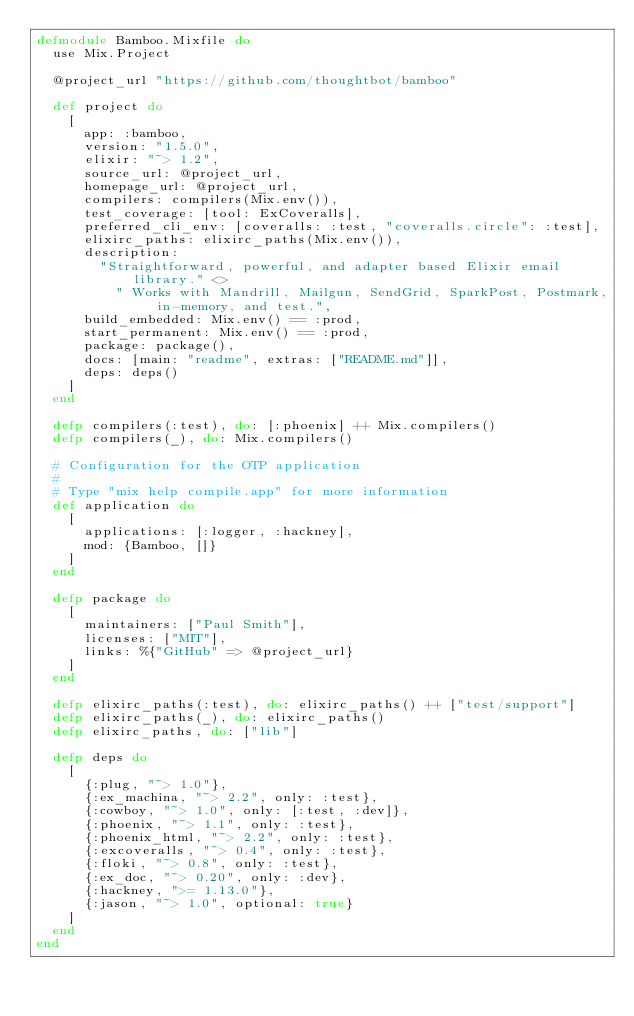Convert code to text. <code><loc_0><loc_0><loc_500><loc_500><_Elixir_>defmodule Bamboo.Mixfile do
  use Mix.Project

  @project_url "https://github.com/thoughtbot/bamboo"

  def project do
    [
      app: :bamboo,
      version: "1.5.0",
      elixir: "~> 1.2",
      source_url: @project_url,
      homepage_url: @project_url,
      compilers: compilers(Mix.env()),
      test_coverage: [tool: ExCoveralls],
      preferred_cli_env: [coveralls: :test, "coveralls.circle": :test],
      elixirc_paths: elixirc_paths(Mix.env()),
      description:
        "Straightforward, powerful, and adapter based Elixir email library." <>
          " Works with Mandrill, Mailgun, SendGrid, SparkPost, Postmark, in-memory, and test.",
      build_embedded: Mix.env() == :prod,
      start_permanent: Mix.env() == :prod,
      package: package(),
      docs: [main: "readme", extras: ["README.md"]],
      deps: deps()
    ]
  end

  defp compilers(:test), do: [:phoenix] ++ Mix.compilers()
  defp compilers(_), do: Mix.compilers()

  # Configuration for the OTP application
  #
  # Type "mix help compile.app" for more information
  def application do
    [
      applications: [:logger, :hackney],
      mod: {Bamboo, []}
    ]
  end

  defp package do
    [
      maintainers: ["Paul Smith"],
      licenses: ["MIT"],
      links: %{"GitHub" => @project_url}
    ]
  end

  defp elixirc_paths(:test), do: elixirc_paths() ++ ["test/support"]
  defp elixirc_paths(_), do: elixirc_paths()
  defp elixirc_paths, do: ["lib"]

  defp deps do
    [
      {:plug, "~> 1.0"},
      {:ex_machina, "~> 2.2", only: :test},
      {:cowboy, "~> 1.0", only: [:test, :dev]},
      {:phoenix, "~> 1.1", only: :test},
      {:phoenix_html, "~> 2.2", only: :test},
      {:excoveralls, "~> 0.4", only: :test},
      {:floki, "~> 0.8", only: :test},
      {:ex_doc, "~> 0.20", only: :dev},
      {:hackney, ">= 1.13.0"},
      {:jason, "~> 1.0", optional: true}
    ]
  end
end
</code> 